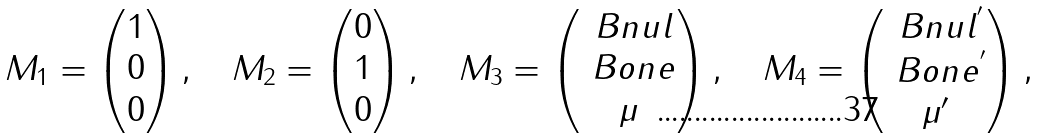<formula> <loc_0><loc_0><loc_500><loc_500>M _ { 1 } = \begin{pmatrix} 1 \\ 0 \\ 0 \end{pmatrix} , \quad M _ { 2 } = \begin{pmatrix} 0 \\ 1 \\ 0 \end{pmatrix} , \quad M _ { 3 } = \begin{pmatrix} \ B n u l \\ \ B o n e \\ \mu \end{pmatrix} , \quad M _ { 4 } = \begin{pmatrix} \ B n u l ^ { ^ { \prime } } \\ \ B o n e ^ { ^ { \prime } } \\ \mu ^ { \prime } \end{pmatrix} ,</formula> 